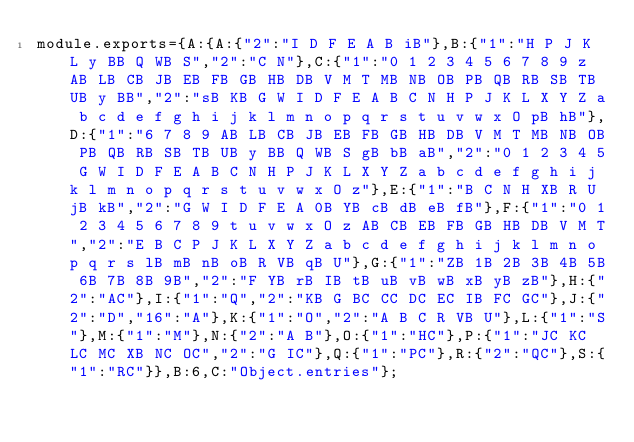<code> <loc_0><loc_0><loc_500><loc_500><_JavaScript_>module.exports={A:{A:{"2":"I D F E A B iB"},B:{"1":"H P J K L y BB Q WB S","2":"C N"},C:{"1":"0 1 2 3 4 5 6 7 8 9 z AB LB CB JB EB FB GB HB DB V M T MB NB OB PB QB RB SB TB UB y BB","2":"sB KB G W I D F E A B C N H P J K L X Y Z a b c d e f g h i j k l m n o p q r s t u v w x O pB hB"},D:{"1":"6 7 8 9 AB LB CB JB EB FB GB HB DB V M T MB NB OB PB QB RB SB TB UB y BB Q WB S gB bB aB","2":"0 1 2 3 4 5 G W I D F E A B C N H P J K L X Y Z a b c d e f g h i j k l m n o p q r s t u v w x O z"},E:{"1":"B C N H XB R U jB kB","2":"G W I D F E A 0B YB cB dB eB fB"},F:{"1":"0 1 2 3 4 5 6 7 8 9 t u v w x O z AB CB EB FB GB HB DB V M T","2":"E B C P J K L X Y Z a b c d e f g h i j k l m n o p q r s lB mB nB oB R VB qB U"},G:{"1":"ZB 1B 2B 3B 4B 5B 6B 7B 8B 9B","2":"F YB rB IB tB uB vB wB xB yB zB"},H:{"2":"AC"},I:{"1":"Q","2":"KB G BC CC DC EC IB FC GC"},J:{"2":"D","16":"A"},K:{"1":"O","2":"A B C R VB U"},L:{"1":"S"},M:{"1":"M"},N:{"2":"A B"},O:{"1":"HC"},P:{"1":"JC KC LC MC XB NC OC","2":"G IC"},Q:{"1":"PC"},R:{"2":"QC"},S:{"1":"RC"}},B:6,C:"Object.entries"};
</code> 